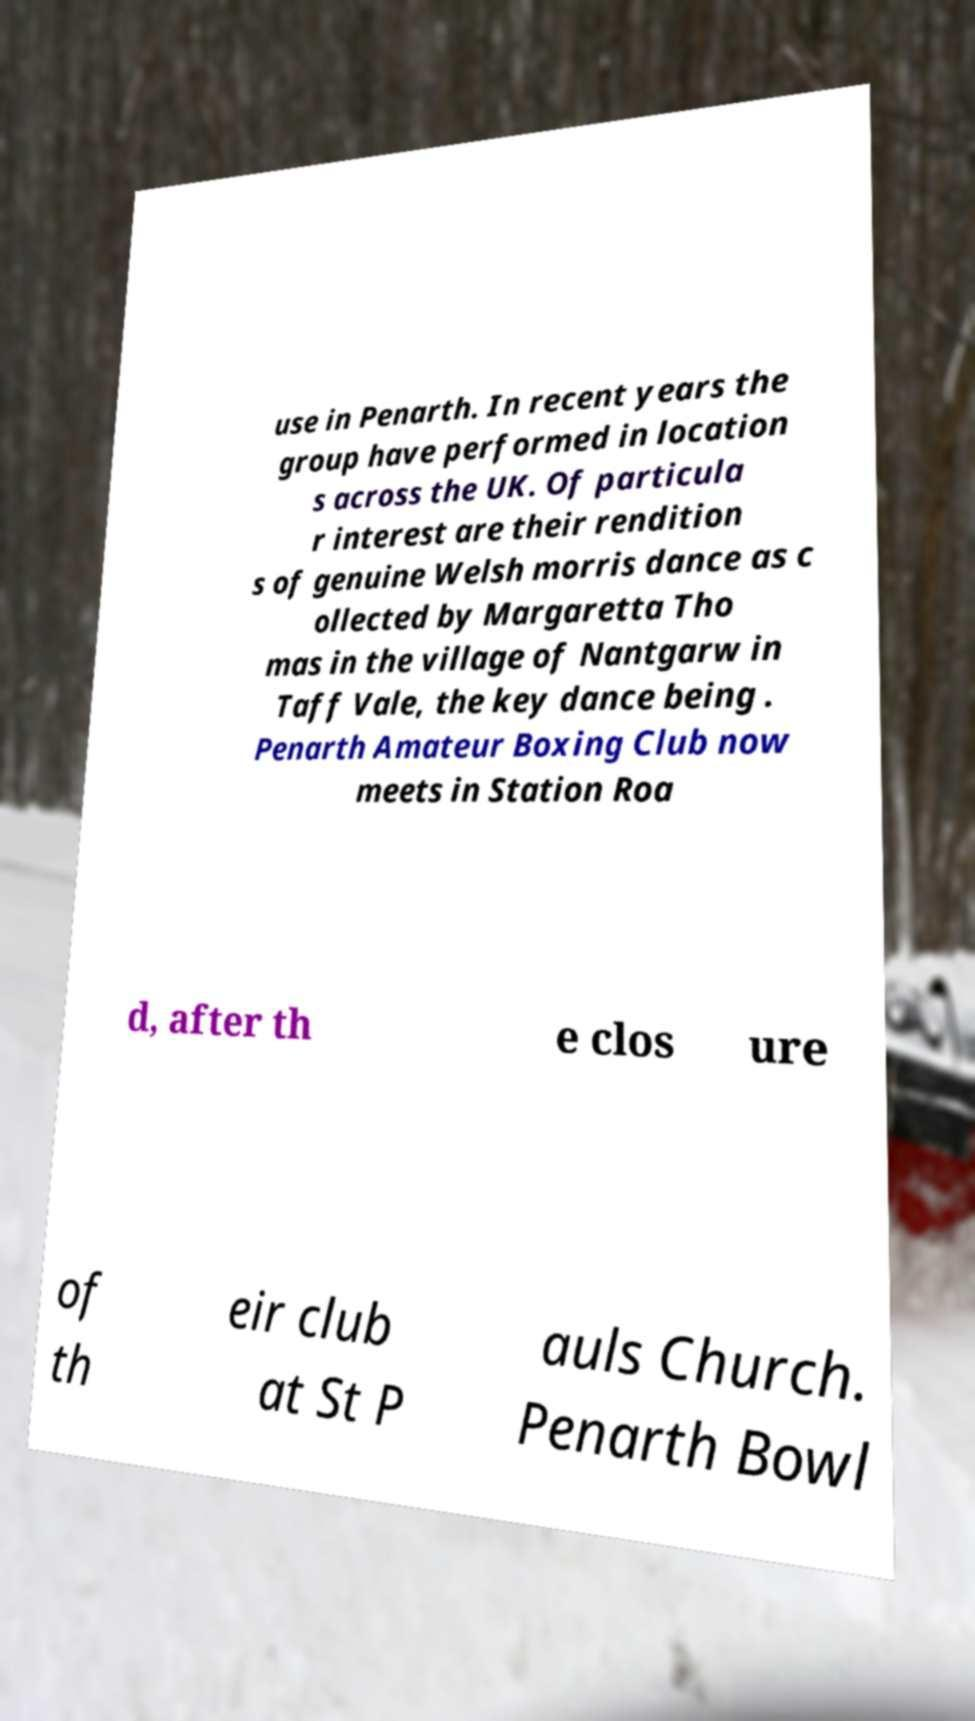For documentation purposes, I need the text within this image transcribed. Could you provide that? use in Penarth. In recent years the group have performed in location s across the UK. Of particula r interest are their rendition s of genuine Welsh morris dance as c ollected by Margaretta Tho mas in the village of Nantgarw in Taff Vale, the key dance being . Penarth Amateur Boxing Club now meets in Station Roa d, after th e clos ure of th eir club at St P auls Church. Penarth Bowl 